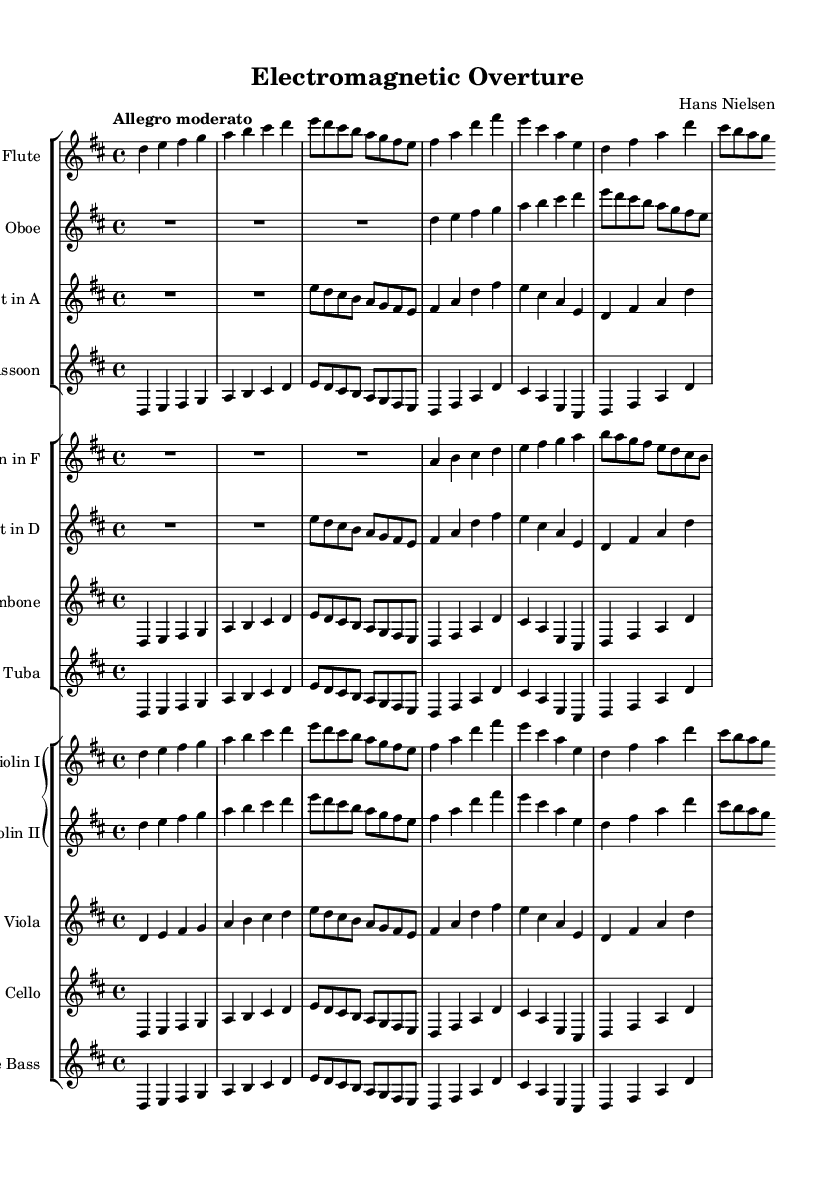What is the key signature of this music? The music is written in D major, which has two sharps: F# and C#. This can be determined by looking at the key signature at the beginning of the score, where two sharp symbols are placed on the staff.
Answer: D major What is the time signature of this music? The time signature is 4/4, as indicated at the beginning of the score with the two numbers stacked vertically. The top number (4) signifies that there are four beats in each measure, and the bottom number (4) indicates that a quarter note receives one beat.
Answer: 4/4 What is the tempo marking of this piece? The tempo marking is "Allegro moderato." This can be found in the header section of the score, showing the desired speed of the piece. "Allegro moderato" suggests a moderately fast pace.
Answer: Allegro moderato How many instrument groups are present in this symphony? There are three instrument groups: woodwinds, brass, and strings. This conclusion can be reached by examining the score layout, where instruments are organized into separate staff groups based on their families.
Answer: Three Which instruments are featured in the woodwinds section? The woodwinds section includes flute, oboe, clarinet, and bassoon. This can be identified by the first staff group that contains these specific instruments listed one after another.
Answer: Flute, oboe, clarinet, bassoon What is the structure of the strings section? The strings section consists of two violin parts, viola, cello, and double bass. This structure is visible in the score layout under the grand staff section, where each instrument is appropriately labeled and organized.
Answer: Two violins, viola, cello, double bass Which instrument plays the highest pitch in this symphony? The flute is the highest-pitched instrument in this symphony. This determination can be made by comparing the written notes on the staff; the flute's part starts an octave higher than the other instruments in the woodwinds group.
Answer: Flute 